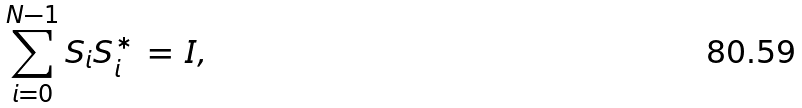Convert formula to latex. <formula><loc_0><loc_0><loc_500><loc_500>\sum _ { i = 0 } ^ { N - 1 } S _ { i } S _ { i } ^ { \ast } \, = \, I ,</formula> 